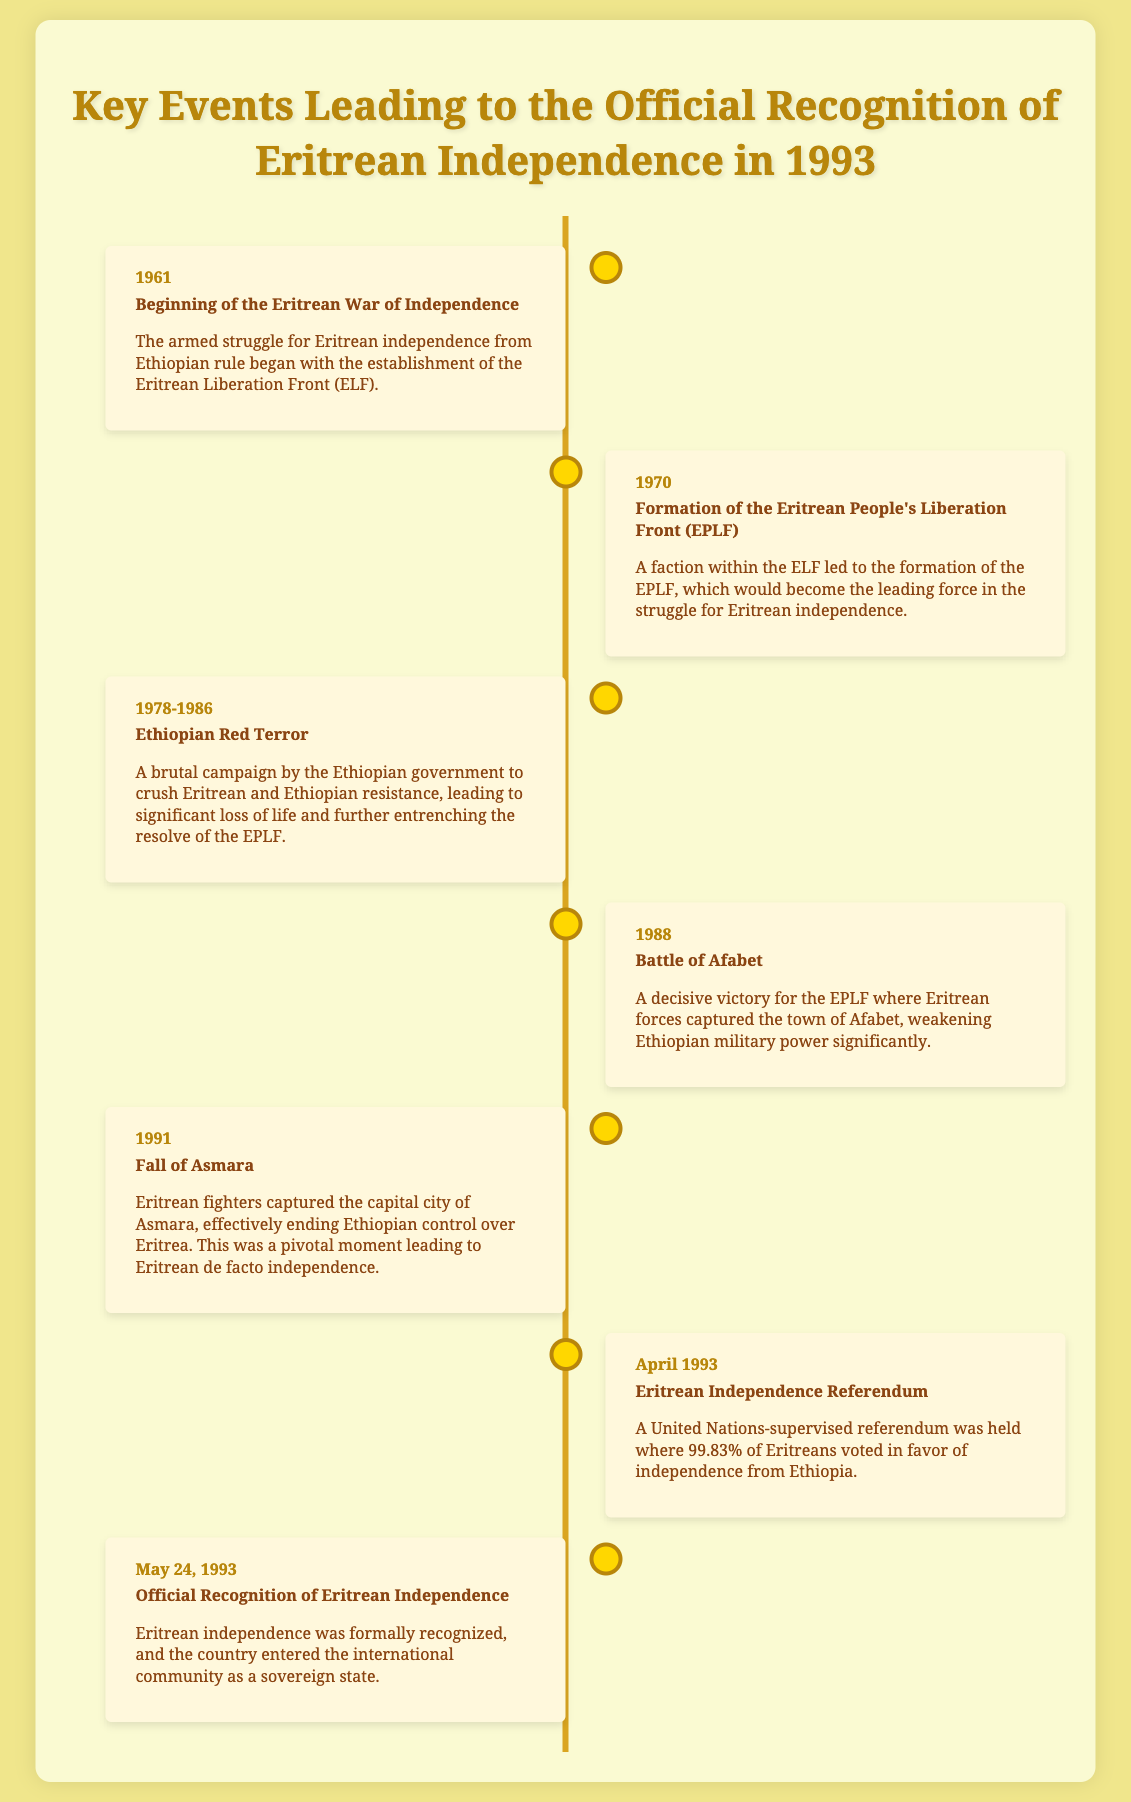what year did the Eritrean War of Independence begin? The document states that the Eritrean War of Independence began in 1961.
Answer: 1961 who formed the Eritrean People's Liberation Front? A faction within the ELF led to the formation of the EPLF.
Answer: The ELF what was a significant event during the Ethiopian Red Terror? The document describes a brutal campaign leading to significant loss of life during this period.
Answer: Loss of life what major battle took place in 1988? The document mentions the Battle of Afabet as a decisive victory for the EPLF.
Answer: Battle of Afabet what percentage of Eritreans voted for independence in the April 1993 referendum? According to the document, 99.83% of Eritreans voted in favor of independence.
Answer: 99.83% what city did Eritrean fighters capture in 1991? The document states that Eritrean fighters captured the capital city of Asmara in 1991.
Answer: Asmara what is the date of the official recognition of Eritrean independence? The document indicates that the official recognition took place on May 24, 1993.
Answer: May 24, 1993 how many years spanned the Eritrean War of Independence from its start until official recognition? The document indicates the war began in 1961 and recognition was in 1993, leading to a span of 32 years.
Answer: 32 years which organization supervised the Eritrean independence referendum? The document mentions that the United Nations supervised the referendum.
Answer: United Nations 